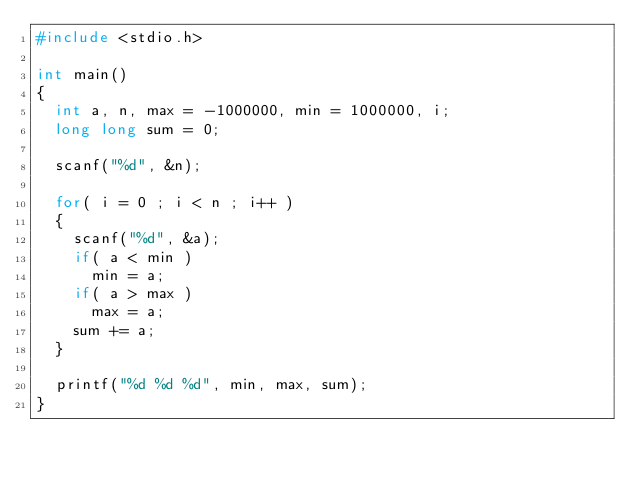Convert code to text. <code><loc_0><loc_0><loc_500><loc_500><_C_>#include <stdio.h>

int main()
{
  int a, n, max = -1000000, min = 1000000, i;
  long long sum = 0;

  scanf("%d", &n);

  for( i = 0 ; i < n ; i++ )
  {
    scanf("%d", &a);
    if( a < min )
      min = a;
    if( a > max )
      max = a;
    sum += a;
  }

  printf("%d %d %d", min, max, sum);
}

</code> 